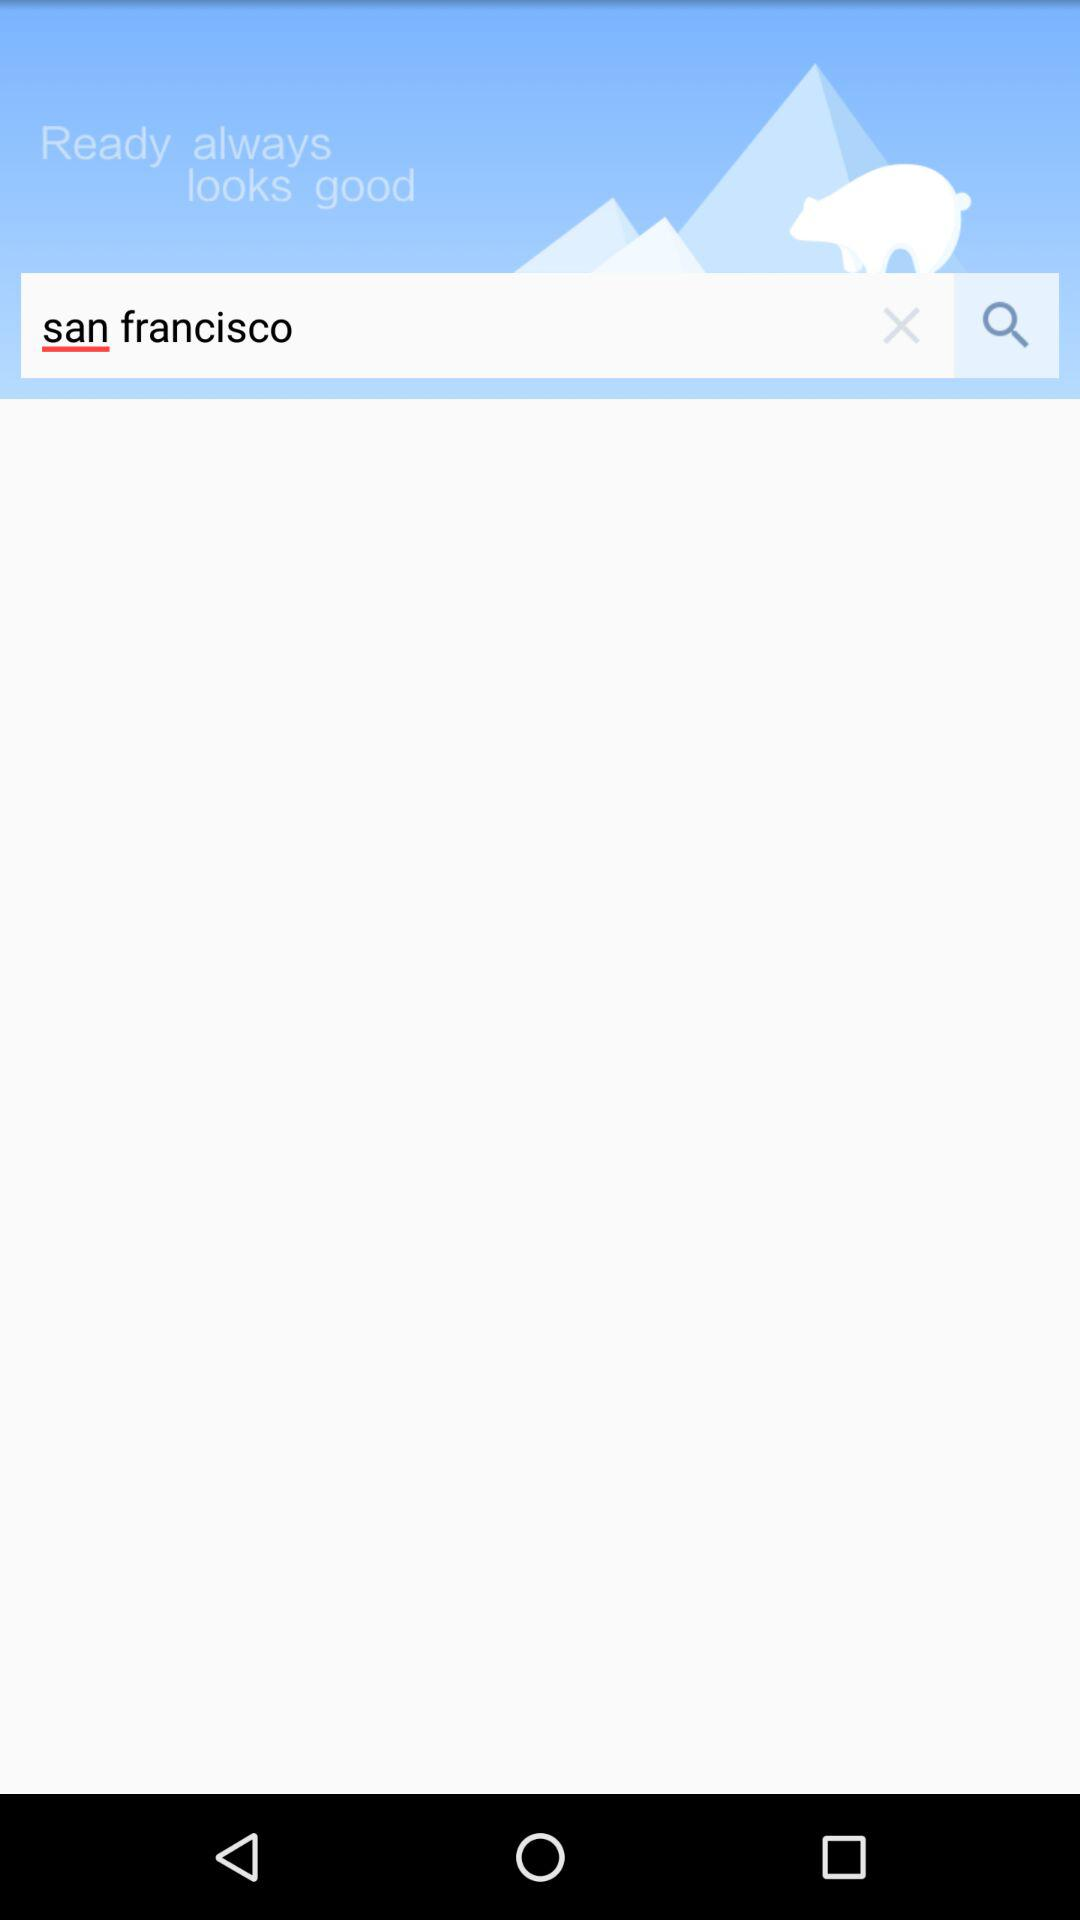What is the name of the application?
When the provided information is insufficient, respond with <no answer>. <no answer> 